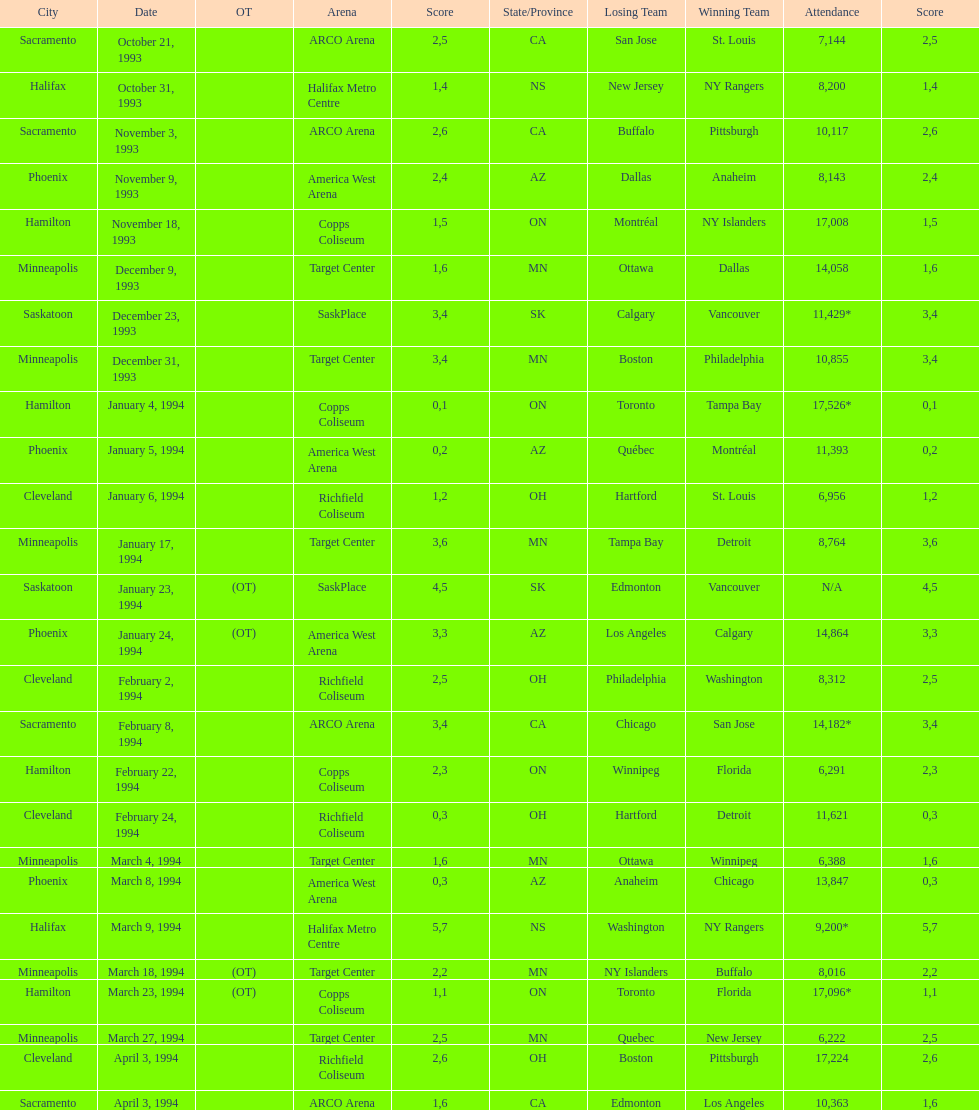Did dallas or ottawa win the december 9, 1993 game? Dallas. 